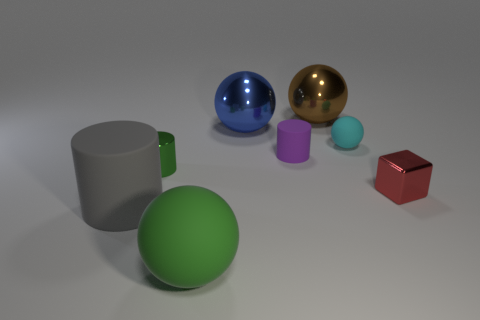Subtract all small cylinders. How many cylinders are left? 1 Add 1 cyan things. How many objects exist? 9 Subtract 1 balls. How many balls are left? 3 Subtract all blue balls. How many balls are left? 3 Subtract all purple balls. Subtract all purple cubes. How many balls are left? 4 Subtract all blocks. How many objects are left? 7 Subtract all large rubber objects. Subtract all brown things. How many objects are left? 5 Add 2 green rubber balls. How many green rubber balls are left? 3 Add 7 big brown objects. How many big brown objects exist? 8 Subtract 0 purple spheres. How many objects are left? 8 